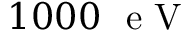Convert formula to latex. <formula><loc_0><loc_0><loc_500><loc_500>1 0 0 0 e V</formula> 